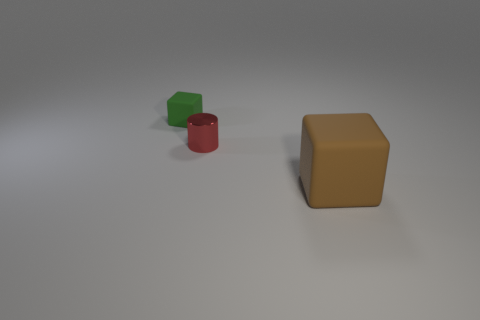Is there anything else that has the same size as the brown rubber object?
Provide a succinct answer. No. How many things are both on the right side of the green matte object and to the left of the brown rubber cube?
Your response must be concise. 1. There is a green block that is the same size as the red metal cylinder; what is it made of?
Provide a short and direct response. Rubber. Does the rubber block behind the brown rubber cube have the same size as the thing right of the tiny red metallic object?
Give a very brief answer. No. There is a red metallic thing; are there any small cylinders to the right of it?
Your answer should be compact. No. There is a cube in front of the small thing in front of the tiny green rubber cube; what color is it?
Your answer should be compact. Brown. Is the number of small green matte objects less than the number of large brown balls?
Your answer should be compact. No. How many big rubber objects are the same shape as the small matte object?
Make the answer very short. 1. The cube that is the same size as the red cylinder is what color?
Make the answer very short. Green. Are there the same number of small things that are in front of the tiny matte block and big rubber cubes that are behind the red metal cylinder?
Your answer should be compact. No. 